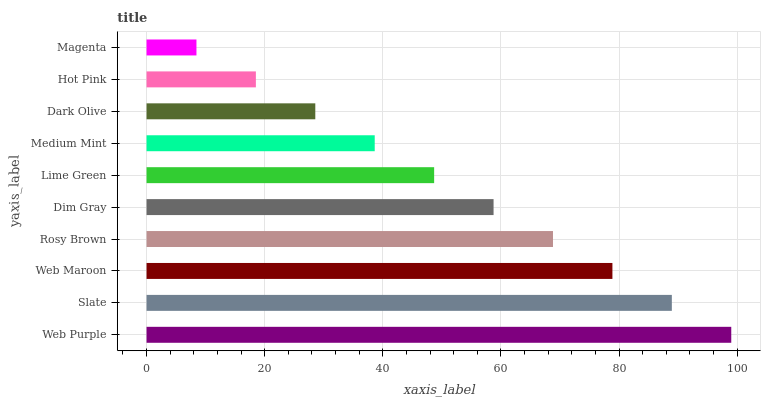Is Magenta the minimum?
Answer yes or no. Yes. Is Web Purple the maximum?
Answer yes or no. Yes. Is Slate the minimum?
Answer yes or no. No. Is Slate the maximum?
Answer yes or no. No. Is Web Purple greater than Slate?
Answer yes or no. Yes. Is Slate less than Web Purple?
Answer yes or no. Yes. Is Slate greater than Web Purple?
Answer yes or no. No. Is Web Purple less than Slate?
Answer yes or no. No. Is Dim Gray the high median?
Answer yes or no. Yes. Is Lime Green the low median?
Answer yes or no. Yes. Is Web Purple the high median?
Answer yes or no. No. Is Medium Mint the low median?
Answer yes or no. No. 